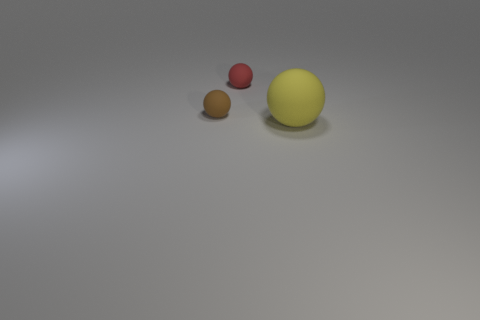There is a tiny red ball; are there any small objects in front of it? Yes, in front of the tiny red ball, there is a small brown object that appears spherical, likely representing another ball. 